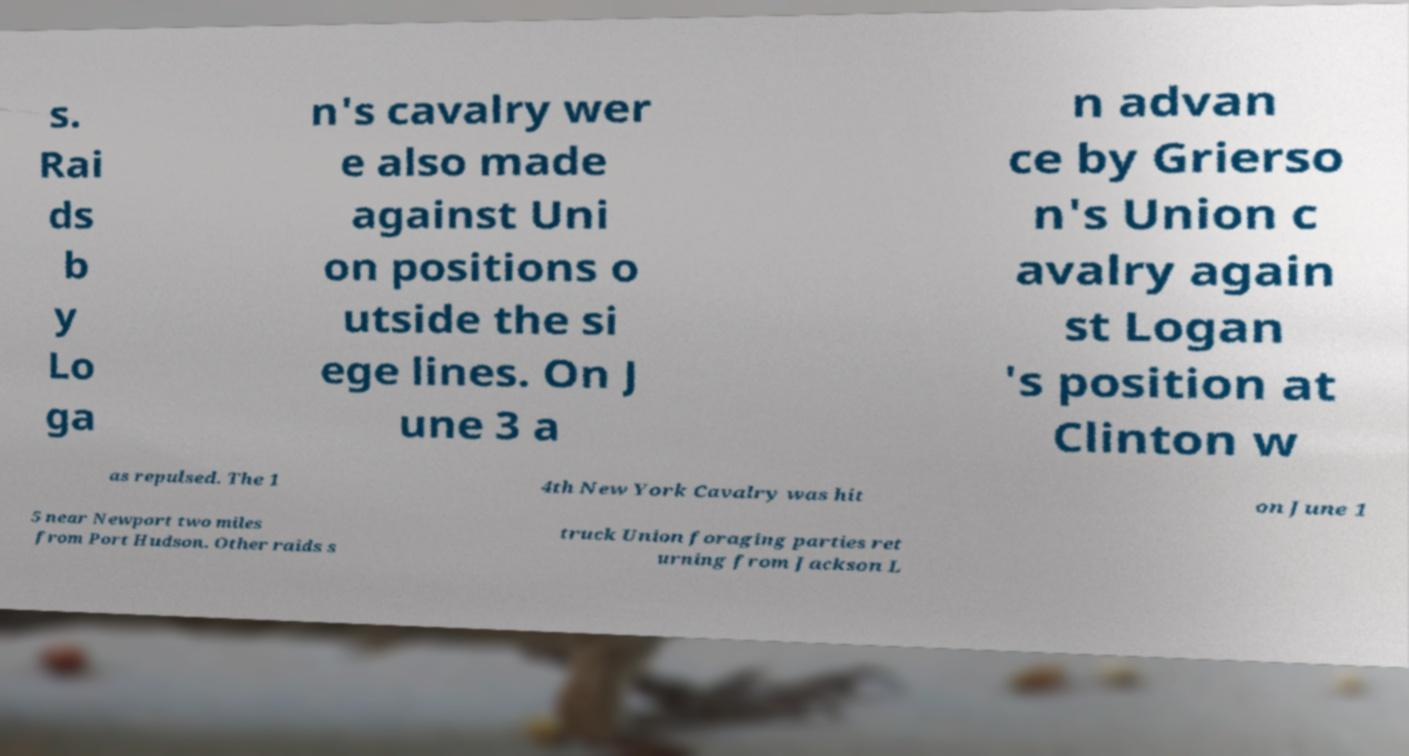I need the written content from this picture converted into text. Can you do that? s. Rai ds b y Lo ga n's cavalry wer e also made against Uni on positions o utside the si ege lines. On J une 3 a n advan ce by Grierso n's Union c avalry again st Logan 's position at Clinton w as repulsed. The 1 4th New York Cavalry was hit on June 1 5 near Newport two miles from Port Hudson. Other raids s truck Union foraging parties ret urning from Jackson L 